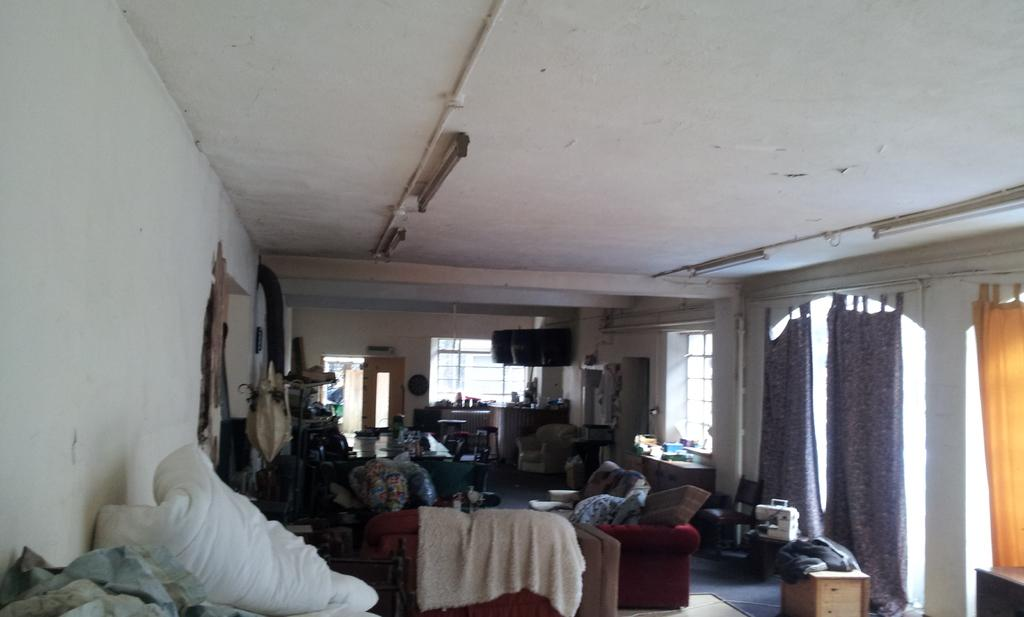What type of furniture is present in the room? There are beds, couches, tables, and cupboards in the room. What can be used for reflecting images in the room? There are mirrors in the room. What provides illumination in the room? There are lights in the room. How can natural light enter the room? There are windows in the room. What can be used to cover the windows in the room? There are curtains in the room. What other objects can be found in the room? There are other objects in the room, but their specific details are not mentioned. What type of plant can be seen growing near the beds in the room? There is no mention of any plants in the room, so it cannot be determined if there is a plant growing near the beds. 